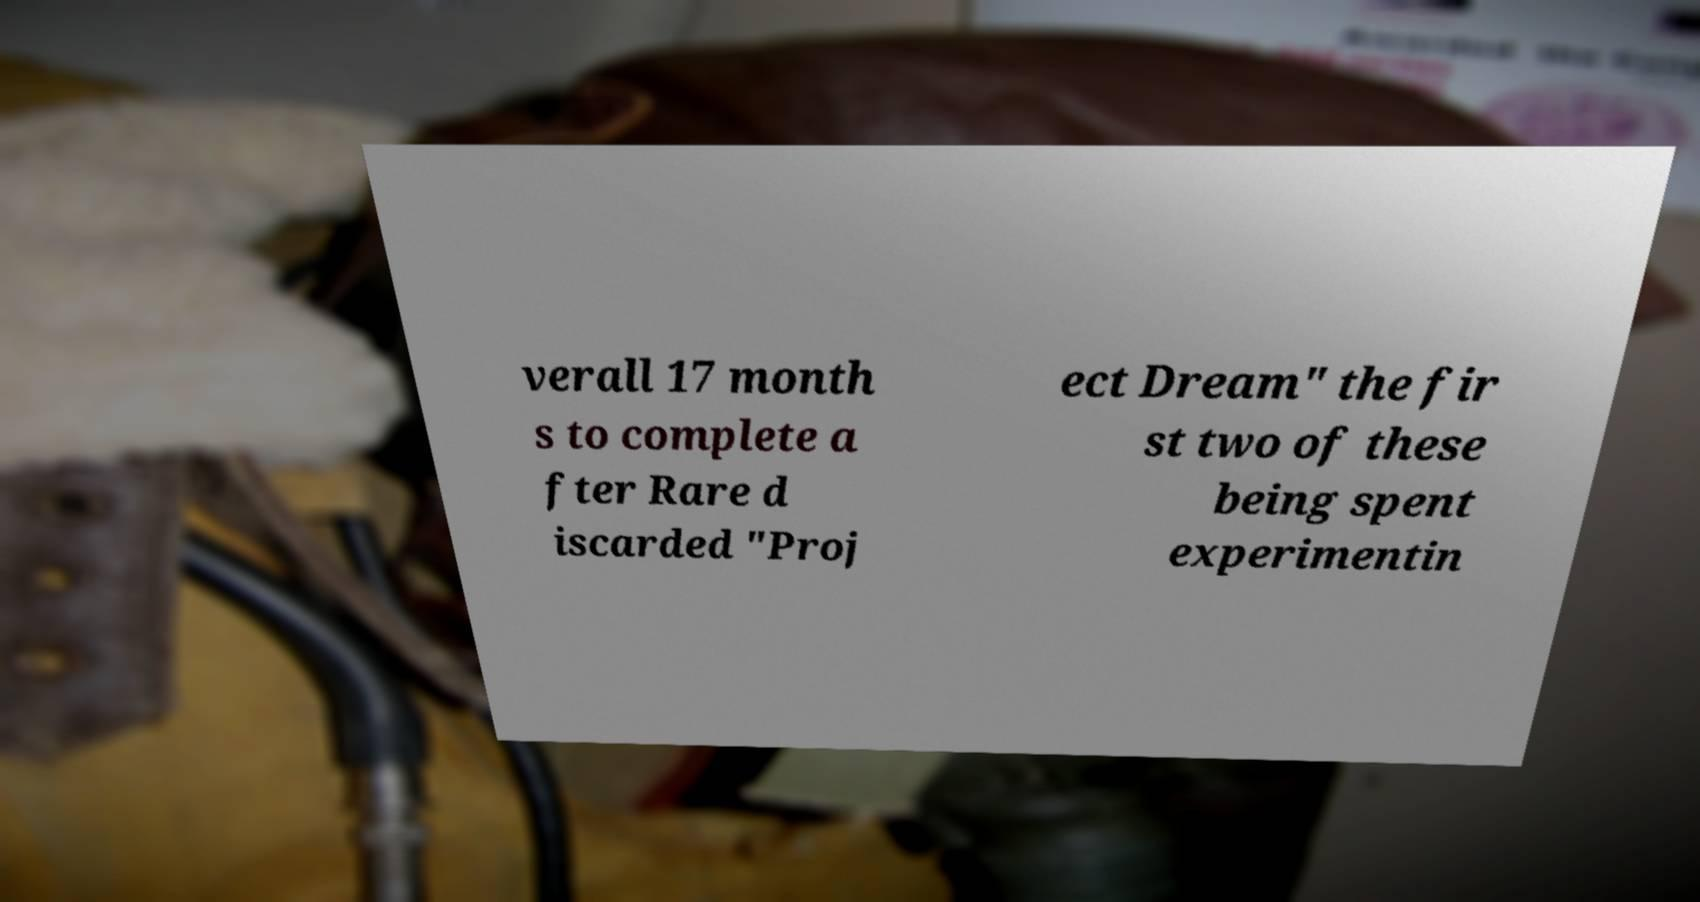Can you accurately transcribe the text from the provided image for me? verall 17 month s to complete a fter Rare d iscarded "Proj ect Dream" the fir st two of these being spent experimentin 